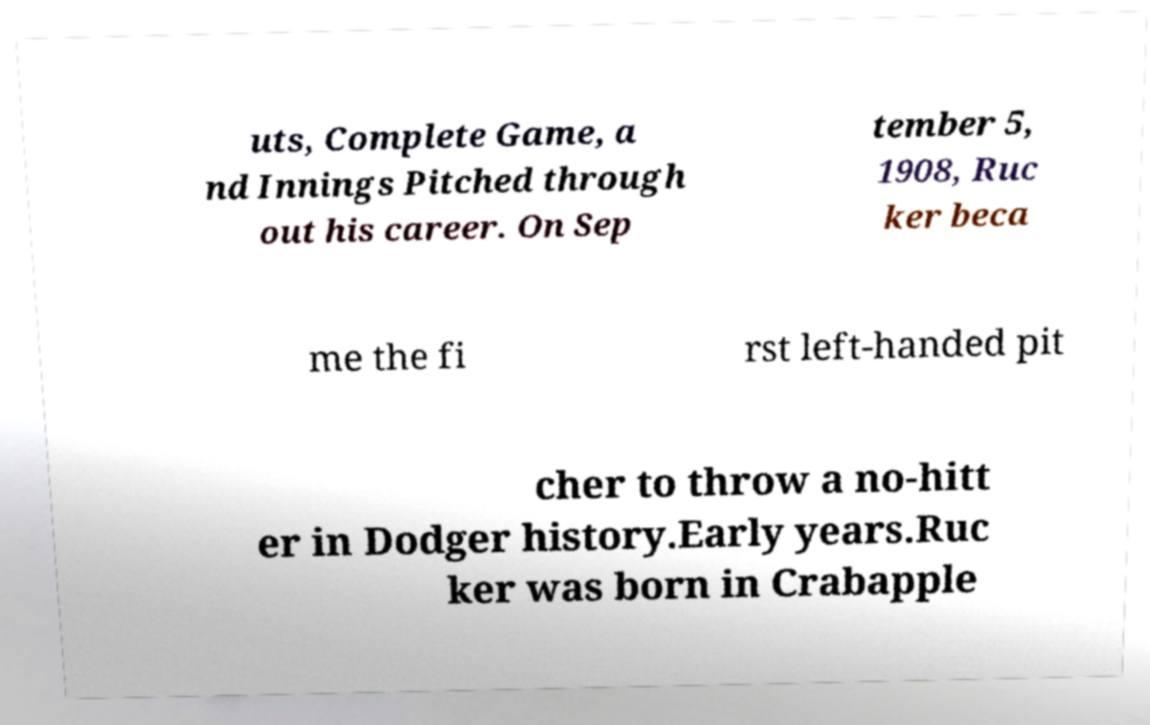For documentation purposes, I need the text within this image transcribed. Could you provide that? uts, Complete Game, a nd Innings Pitched through out his career. On Sep tember 5, 1908, Ruc ker beca me the fi rst left-handed pit cher to throw a no-hitt er in Dodger history.Early years.Ruc ker was born in Crabapple 